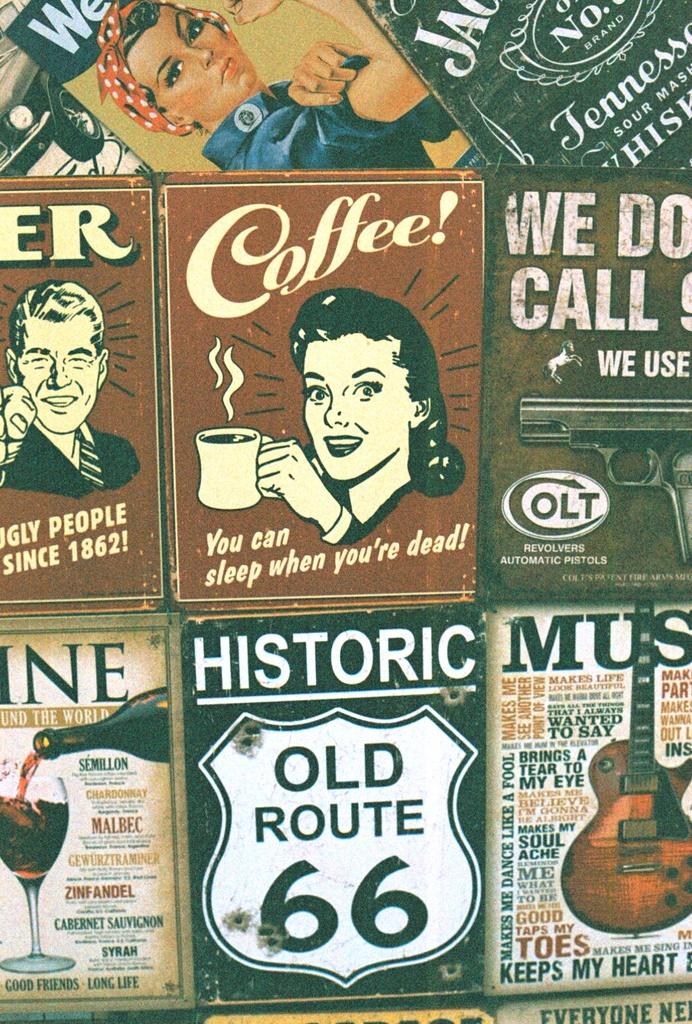What objects are present in the image that resemble vertical supports? There are posts in the image. What are the people doing on the posts? People are depicted on the posts. What musical instrument can be seen in the image? A guitar is visible in the image. What type of beverage might be in the glass? There is a glass with a drink in the image, but the specific beverage is not identifiable. What other container is present in the image? A bottle is present in the image. How many sheep are visible in the image? There are no sheep present in the image. Who is the owner of the guitar in the image? There is no indication of ownership in the image, so it cannot be determined who the owner of the guitar is. 